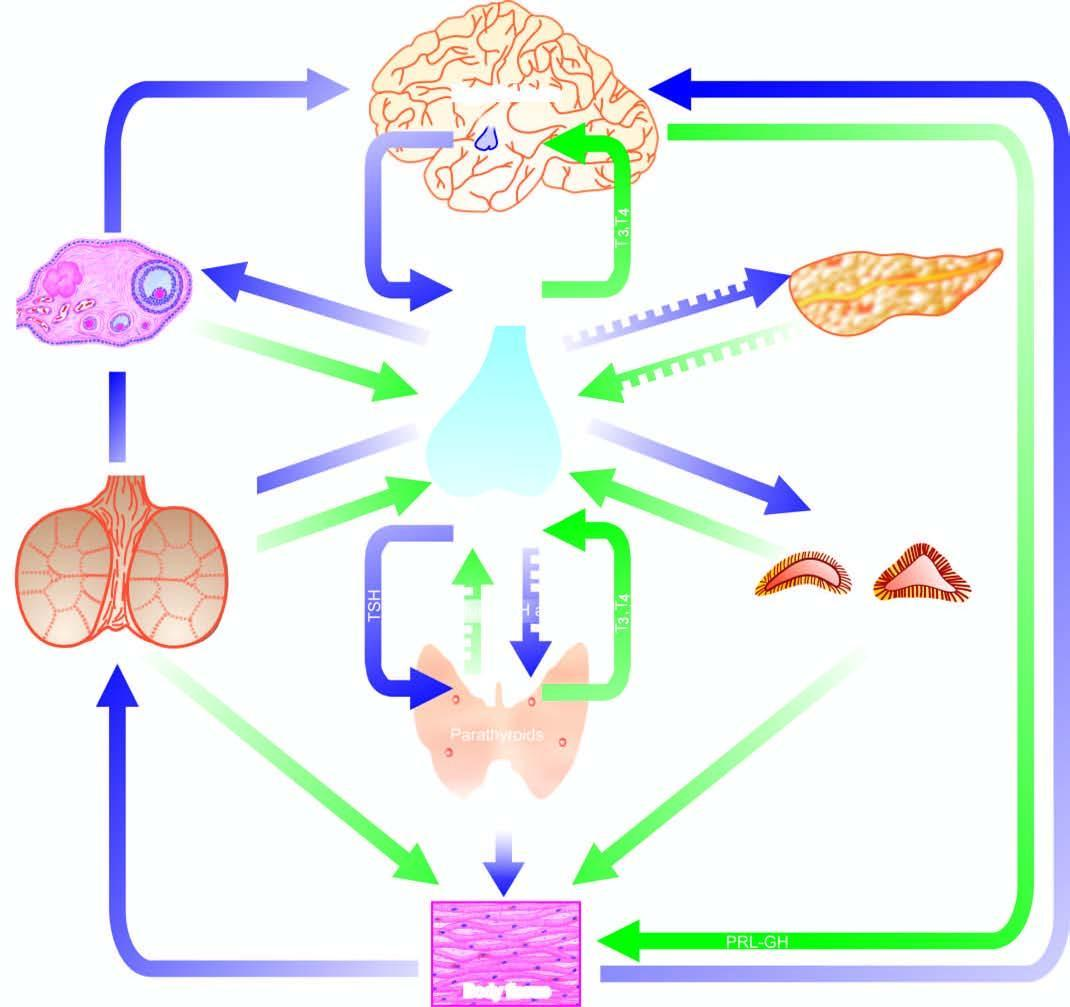what do both positive and negative feedback controls exist for?
Answer the question using a single word or phrase. Each endocrine gland having a regulating hormone 